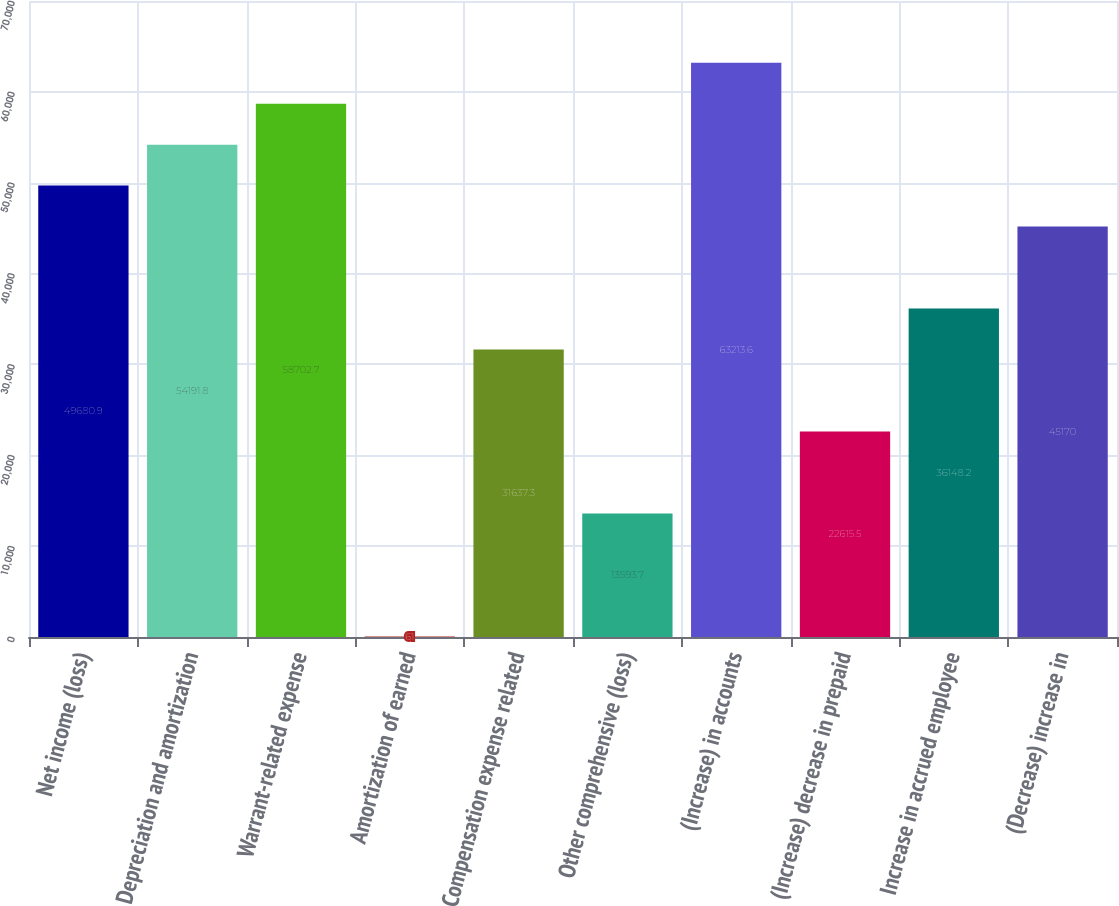Convert chart. <chart><loc_0><loc_0><loc_500><loc_500><bar_chart><fcel>Net income (loss)<fcel>Depreciation and amortization<fcel>Warrant-related expense<fcel>Amortization of earned<fcel>Compensation expense related<fcel>Other comprehensive (loss)<fcel>(Increase) in accounts<fcel>(Increase) decrease in prepaid<fcel>Increase in accrued employee<fcel>(Decrease) increase in<nl><fcel>49680.9<fcel>54191.8<fcel>58702.7<fcel>61<fcel>31637.3<fcel>13593.7<fcel>63213.6<fcel>22615.5<fcel>36148.2<fcel>45170<nl></chart> 